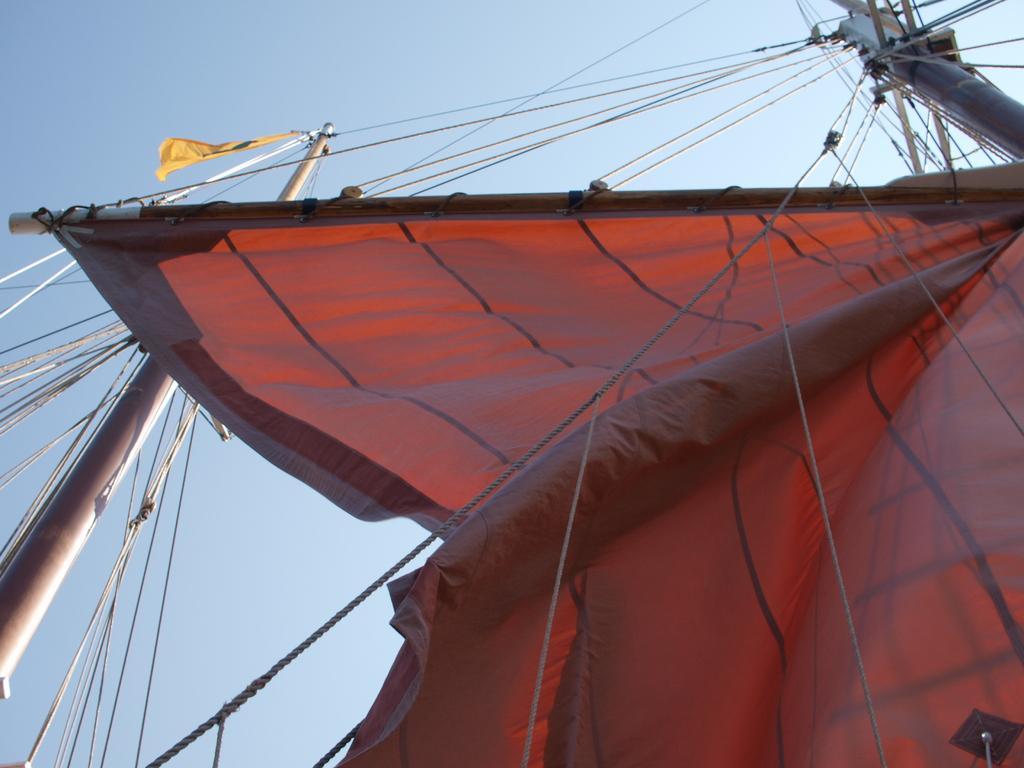In one or two sentences, can you explain what this image depicts? In this we can see two poles connected with wires and ropes, tent, a clear sky. 